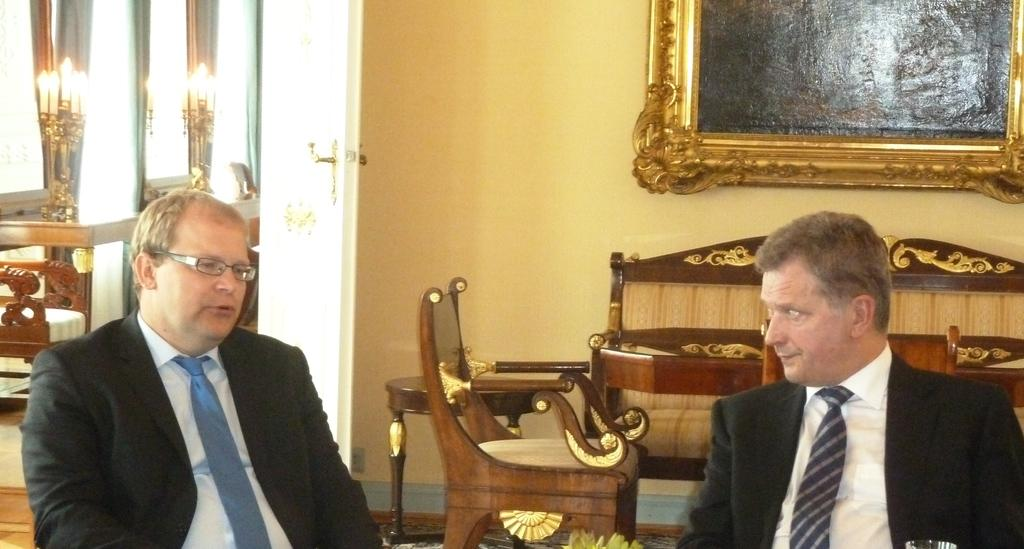How many people are in the image? There are two persons in the image. What are the two persons doing? The two persons are talking to each other. What type of furniture is present in the image? There is a chair and a couch in the image. What can be seen on the wall in the image? There is a frame on the wall in the image. What type of acoustics can be heard in the image? There is no information about the acoustics in the image, as it only shows two people talking and the surrounding furniture and frame. What does the dad in the image say to his child? There is no mention of a dad or a child in the image; it only features two people talking. 